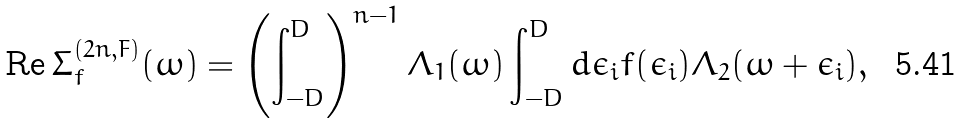Convert formula to latex. <formula><loc_0><loc_0><loc_500><loc_500>\text {Re\,} \Sigma ^ { ( 2 n , F ) } _ { f } ( \omega ) = \left ( \int _ { - D } ^ { D } \right ) ^ { n - 1 } \Lambda _ { 1 } ( \omega ) \int _ { - D } ^ { D } d \epsilon _ { i } f ( \epsilon _ { i } ) \Lambda _ { 2 } ( \omega + \epsilon _ { i } ) ,</formula> 